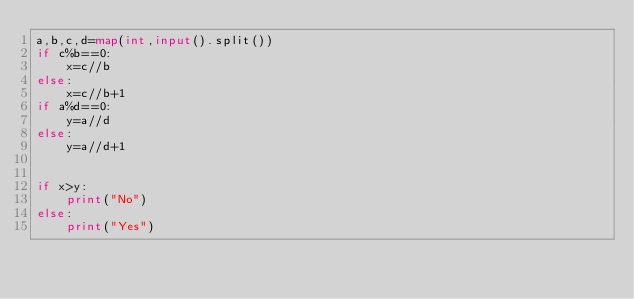<code> <loc_0><loc_0><loc_500><loc_500><_Python_>a,b,c,d=map(int,input().split())
if c%b==0:
    x=c//b
else:
    x=c//b+1
if a%d==0:
    y=a//d
else:
    y=a//d+1


if x>y:
    print("No")
else:
    print("Yes")</code> 